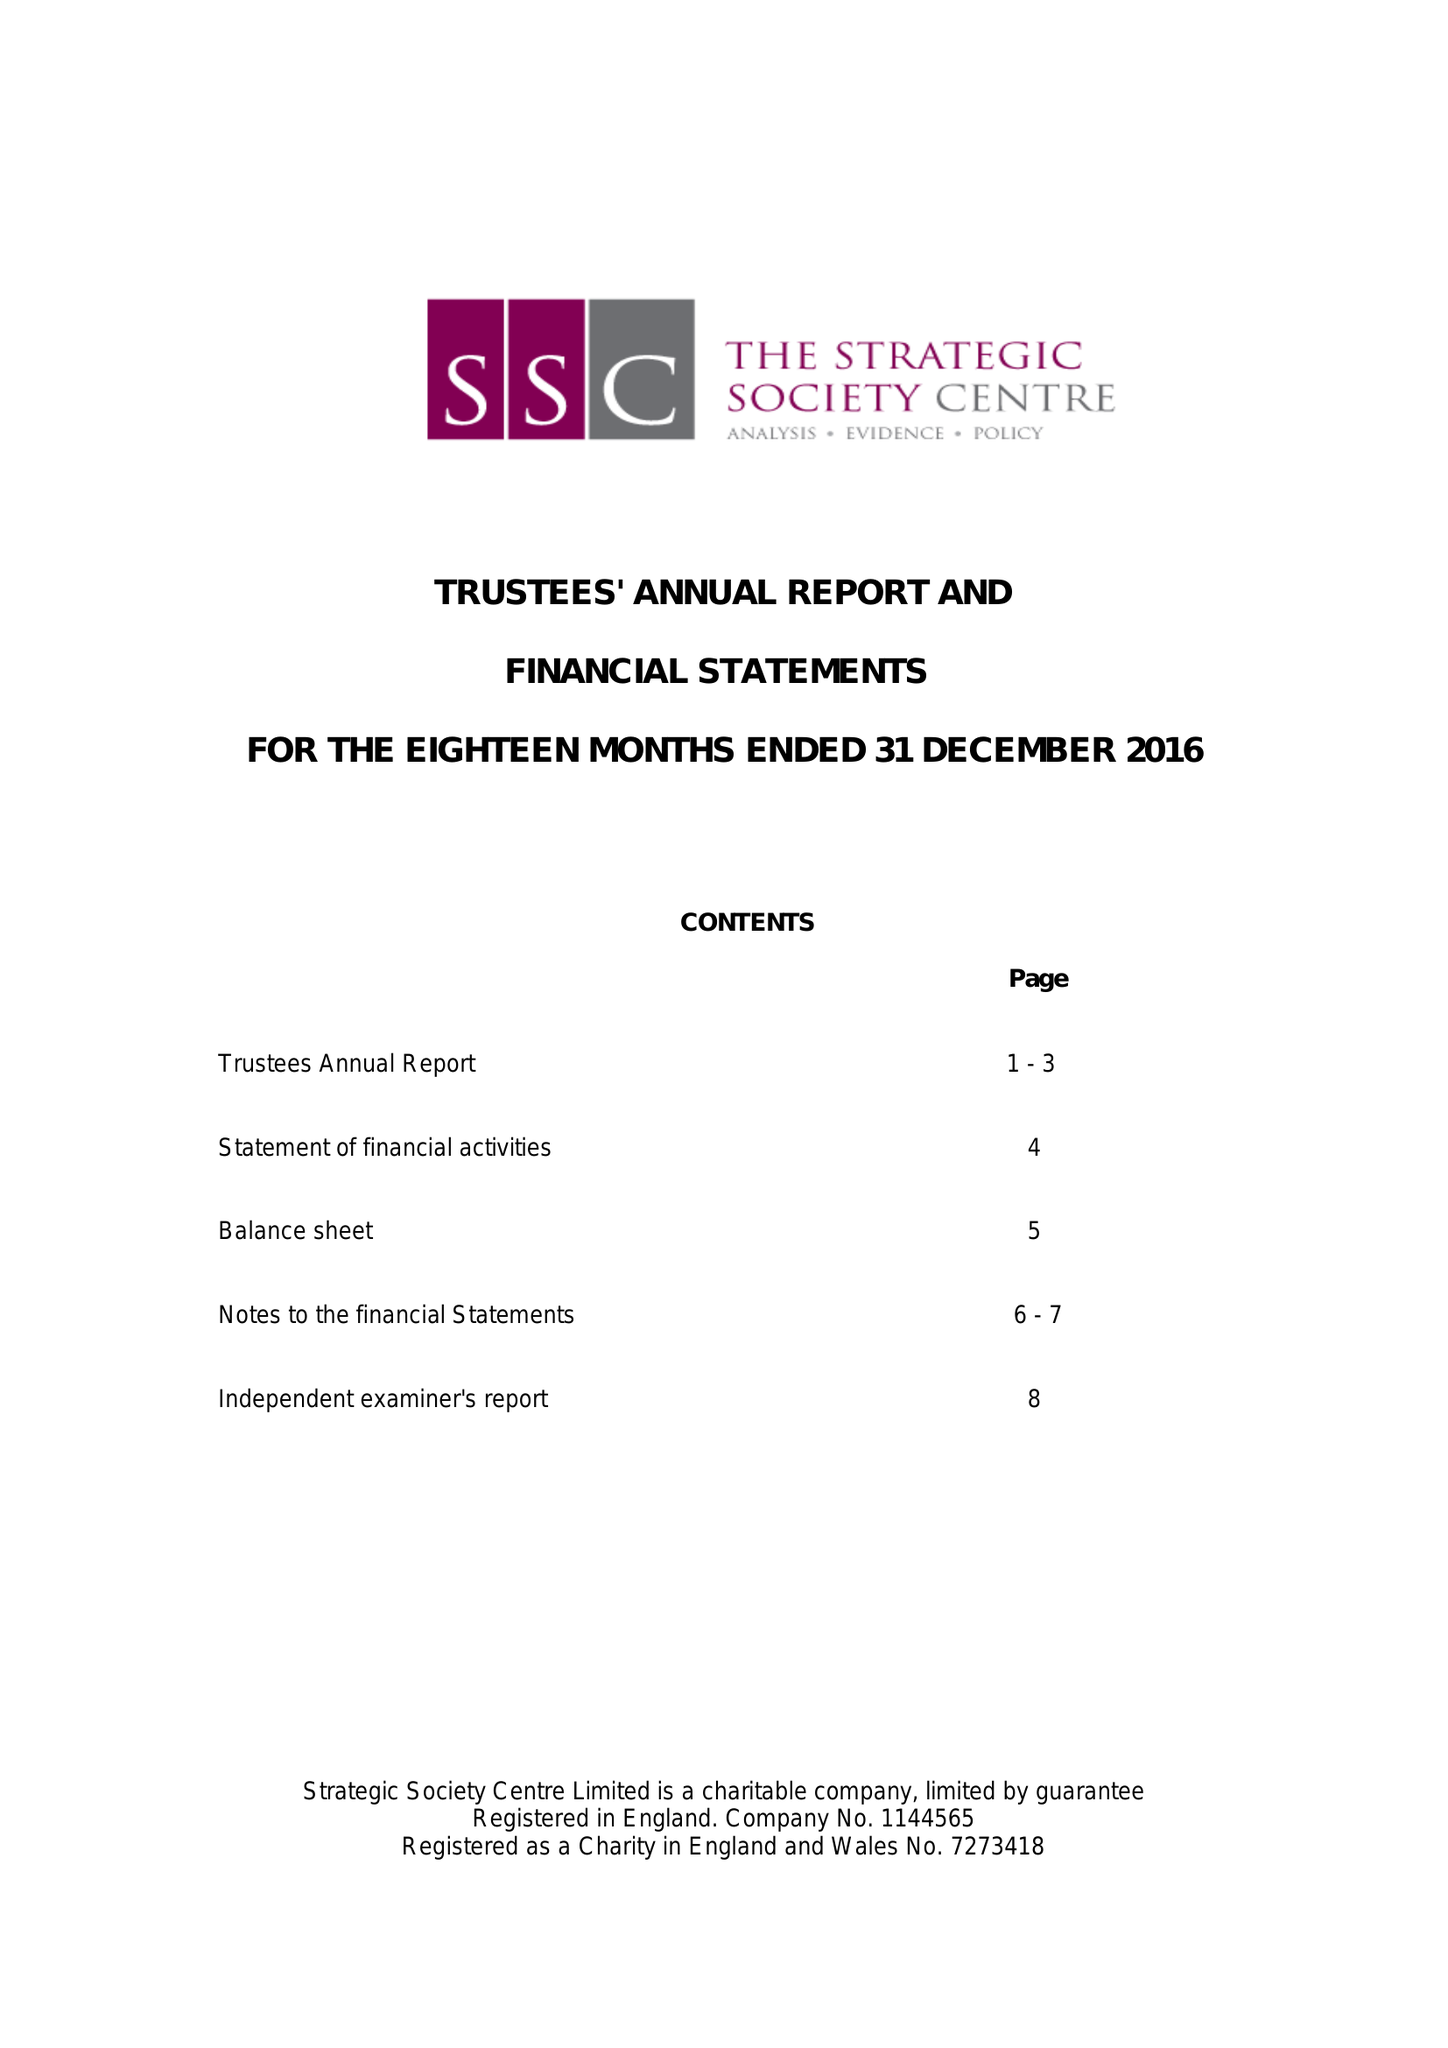What is the value for the income_annually_in_british_pounds?
Answer the question using a single word or phrase. 55587.00 